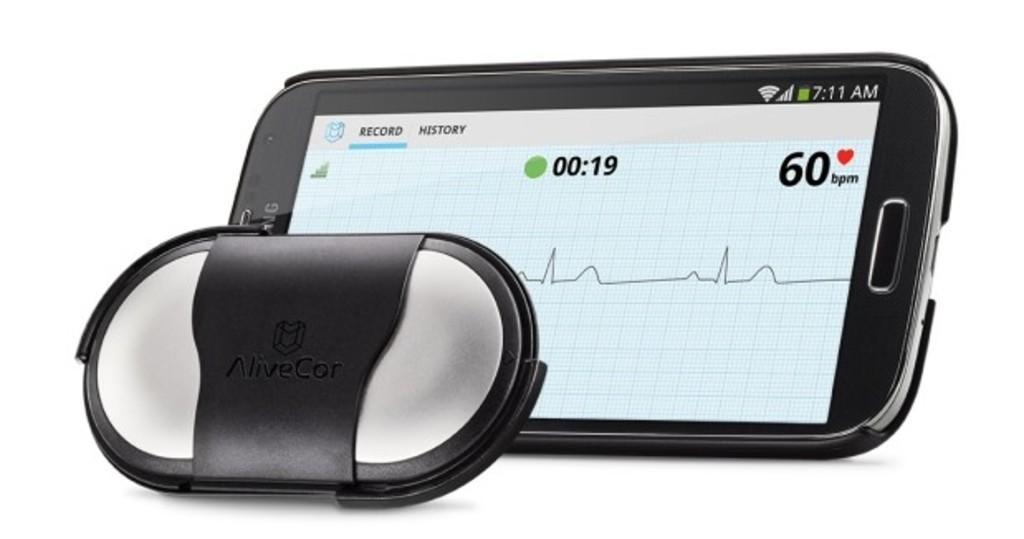How many seconds has it been tracking for?
Your answer should be compact. 19. What is this person's heartrate?
Provide a short and direct response. 60. 